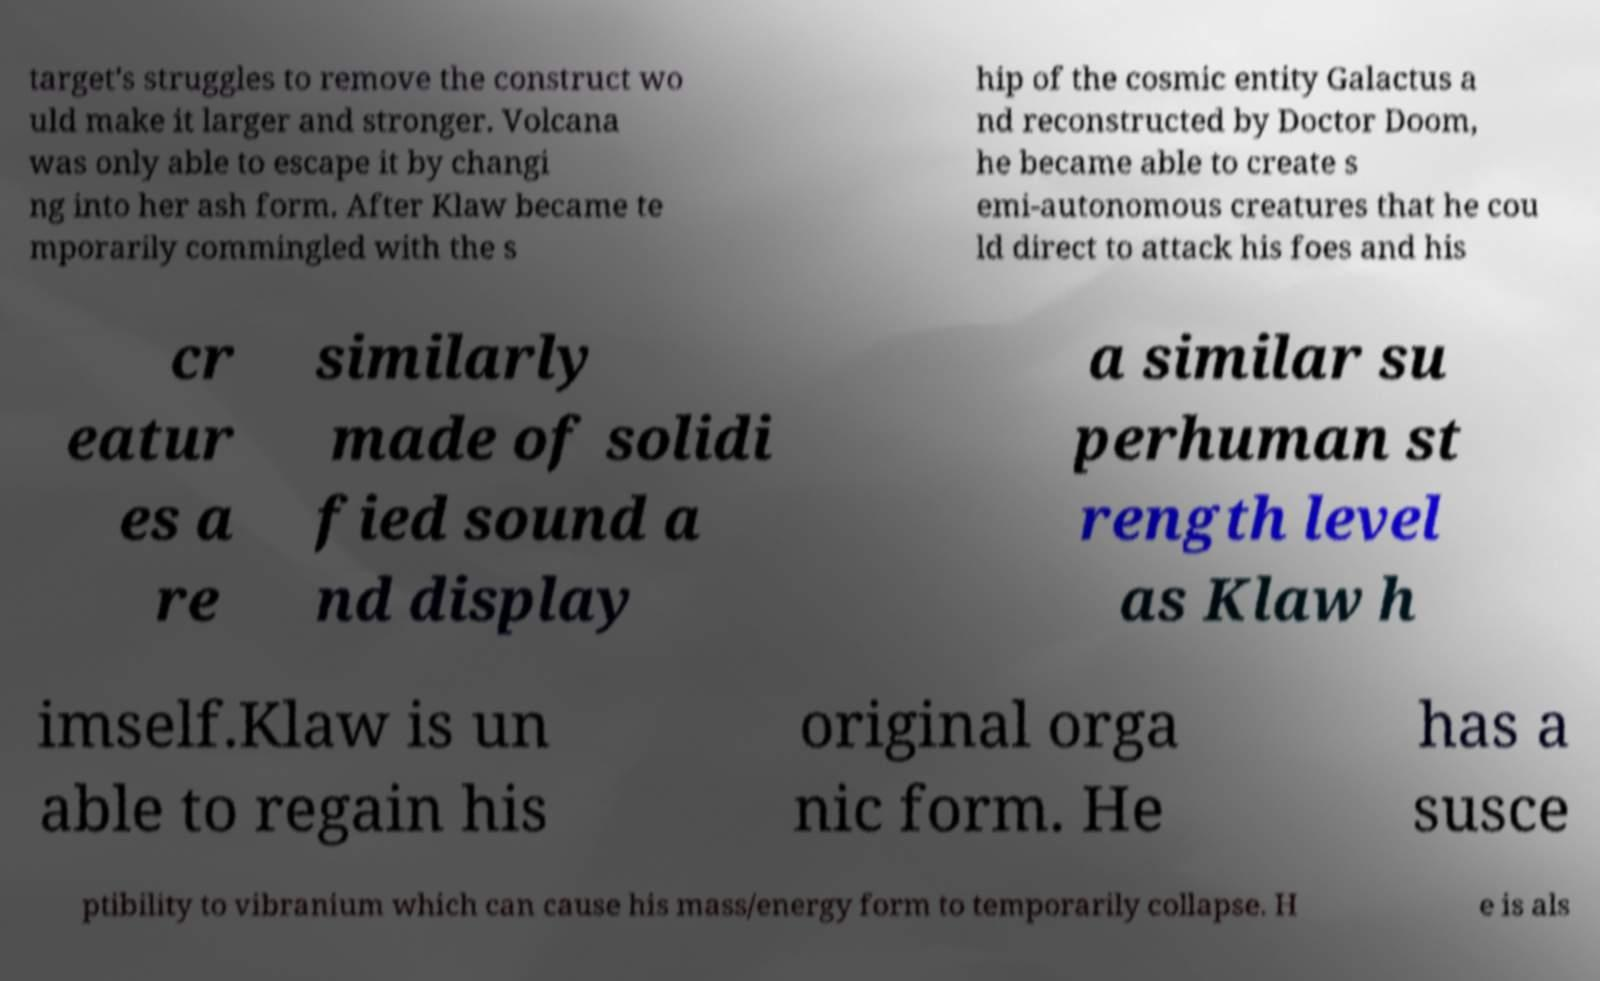For documentation purposes, I need the text within this image transcribed. Could you provide that? target's struggles to remove the construct wo uld make it larger and stronger. Volcana was only able to escape it by changi ng into her ash form. After Klaw became te mporarily commingled with the s hip of the cosmic entity Galactus a nd reconstructed by Doctor Doom, he became able to create s emi-autonomous creatures that he cou ld direct to attack his foes and his cr eatur es a re similarly made of solidi fied sound a nd display a similar su perhuman st rength level as Klaw h imself.Klaw is un able to regain his original orga nic form. He has a susce ptibility to vibranium which can cause his mass/energy form to temporarily collapse. H e is als 